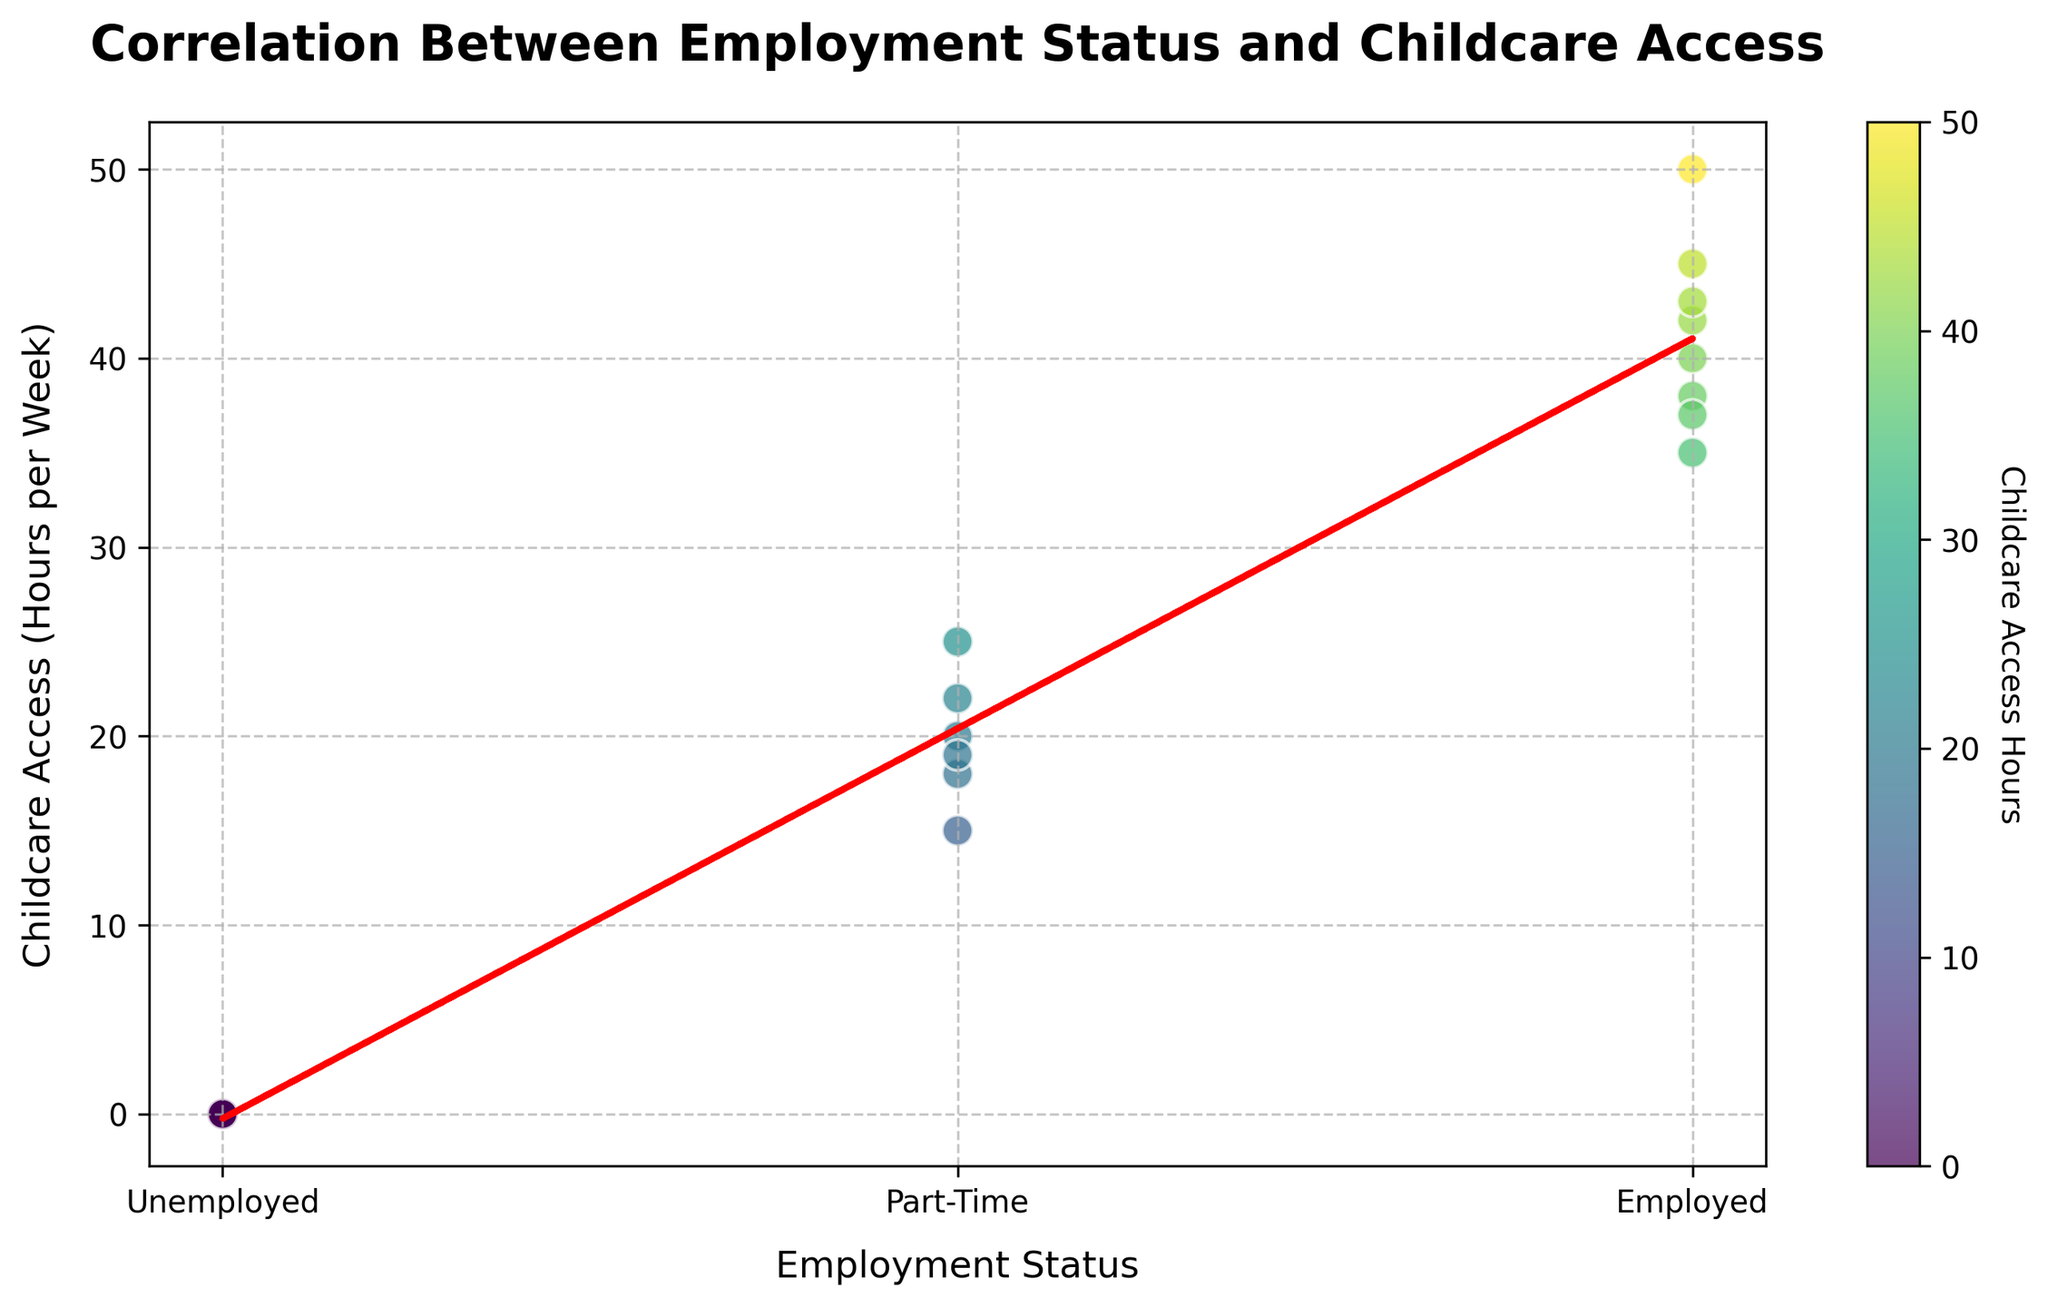What is the title of the scatter plot? The title of the scatter plot is located at the top of the figure in a bold font.
Answer: Correlation Between Employment Status and Childcare Access What does the x-axis represent? The label below the x-axis indicates that it represents 'Employment Status'. There are three categories here: Unemployed, Part-Time, and Employed.
Answer: Employment Status How many employment status levels are represented, and what are they? The x-axis has ticks labeled for three categories. They are Unemployed, Part-Time, and Employed.
Answer: Three levels: Unemployed, Part-Time, Employed What does the y-axis measure? The label next to the y-axis indicates it measures 'Childcare Access (Hours per Week)'.
Answer: Childcare Access (Hours per Week) What color scheme is used for the data points, and what does it represent? The scatter plot uses a color gradient represented by a color bar on the right side of the plot. The color ranges from lighter to darker as the childcare access hours increase.
Answer: Viridis color scheme representing Childcare Access Hours Who accesses the most childcare hours according to the plot? The data point highest on the y-axis, which represents the maximum childcare hours, corresponds to the employment status Employed.
Answer: Employed What trend can you observe from the trend line? The red dotted trend line shows a positive slope from Unemployed to Employed, indicating that access to childcare hours increases with higher employment status.
Answer: Access to childcare increases with employment status Compare the average childcare access hours between Part-Time and Employed categories. Visually estimate the average position of the points for Part-Time and Employed status along the y-axis. The points for Employed status are generally higher on the y-axis compared to Part-Time, indicating higher average childcare hours.
Answer: Higher for Employed Which employment status has the least variation in childcare access hours? Observing the spread of data points, 'Unemployed' status has points clustered at 0 childcare hours, indicating no variation.
Answer: Unemployed How does the trend line change as employment status goes from Unemployed to Employed? The trend line, which is a red dashed line, increases steadily from Unemployed (0) to Employed (2) on the x-axis.
Answer: It increases steadily 